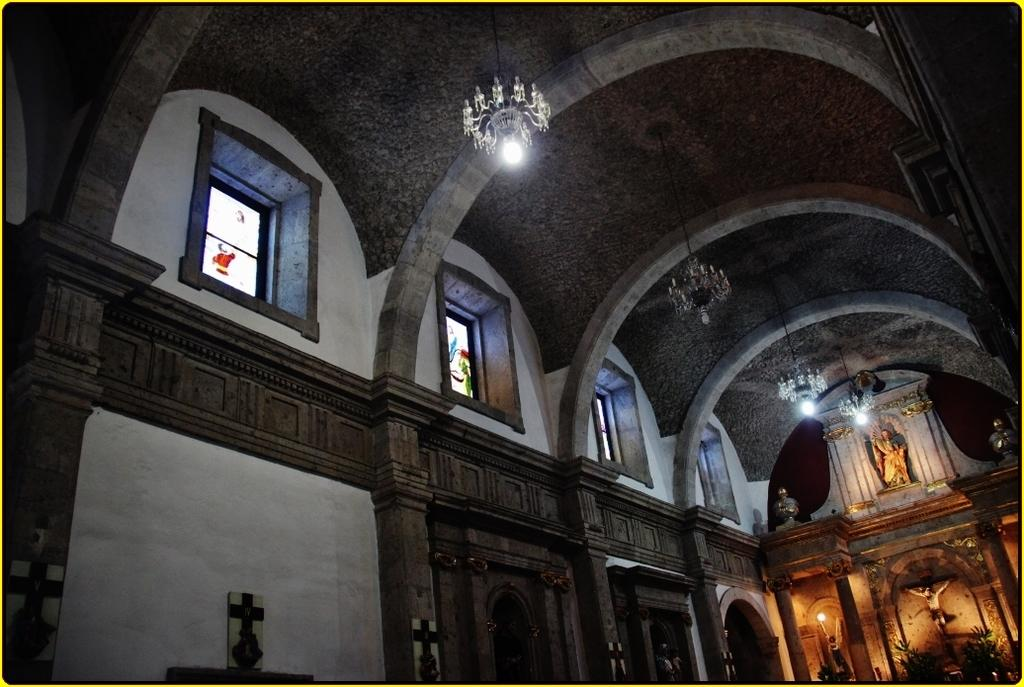What type of architectural feature can be seen in the image? There are arches in the image. What type of artwork is present in the image? There are sculptures in the image. What type of lighting is present in the image? There are lights and lamps in the image. Where are the lights and lamps located in the image? The lights and lamps are attached to the roof. Can you see a crate filled with thumb tacks in the image? No, there is no crate or thumb tacks present in the image. Is there an ocean visible in the image? No, there is no ocean present in the image. 